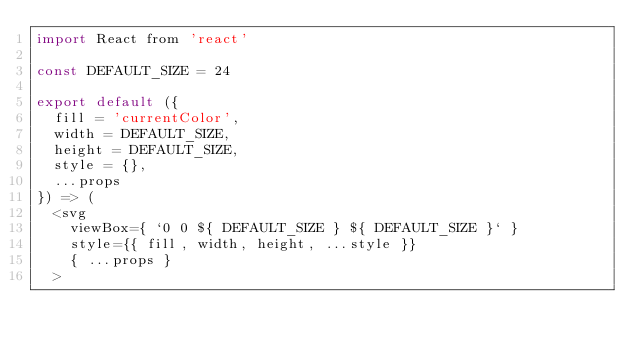Convert code to text. <code><loc_0><loc_0><loc_500><loc_500><_JavaScript_>import React from 'react'

const DEFAULT_SIZE = 24

export default ({
  fill = 'currentColor',
  width = DEFAULT_SIZE,
  height = DEFAULT_SIZE,
  style = {},
  ...props
}) => (
  <svg
    viewBox={ `0 0 ${ DEFAULT_SIZE } ${ DEFAULT_SIZE }` }
    style={{ fill, width, height, ...style }}
    { ...props }
  ></code> 